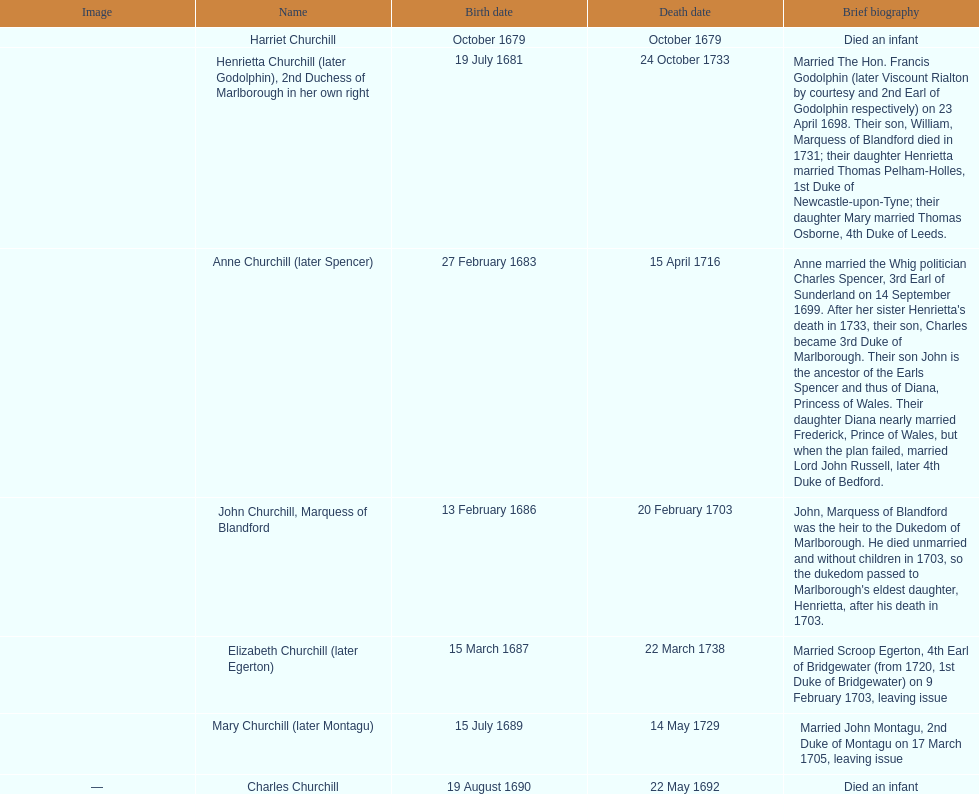What was anne churchill/spencer's lifespan? 33. 